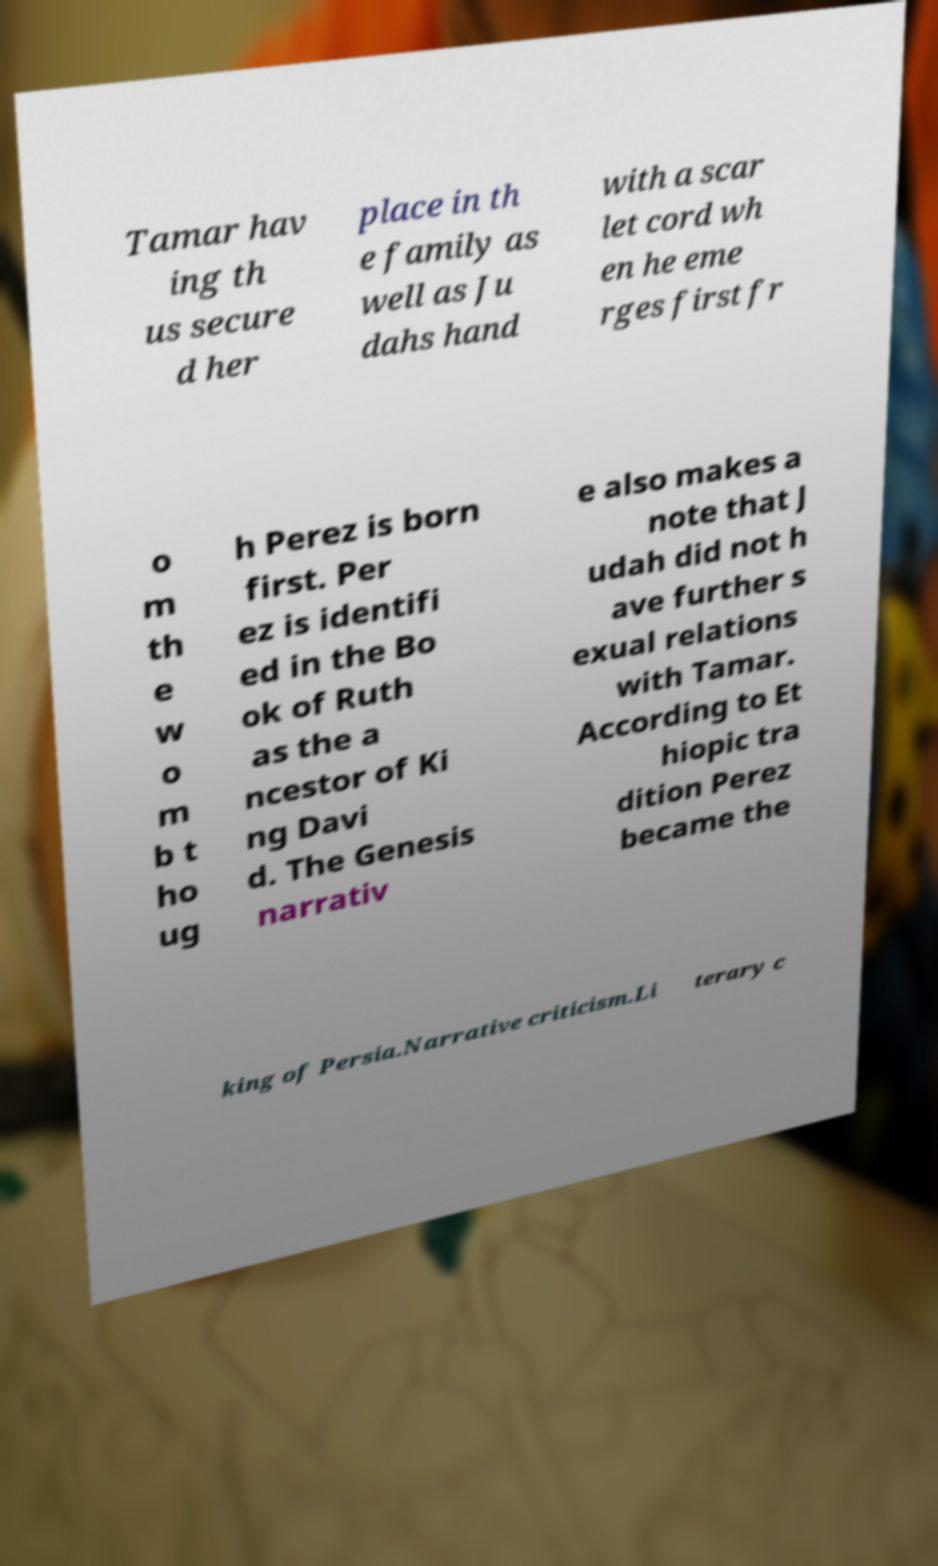For documentation purposes, I need the text within this image transcribed. Could you provide that? Tamar hav ing th us secure d her place in th e family as well as Ju dahs hand with a scar let cord wh en he eme rges first fr o m th e w o m b t ho ug h Perez is born first. Per ez is identifi ed in the Bo ok of Ruth as the a ncestor of Ki ng Davi d. The Genesis narrativ e also makes a note that J udah did not h ave further s exual relations with Tamar. According to Et hiopic tra dition Perez became the king of Persia.Narrative criticism.Li terary c 